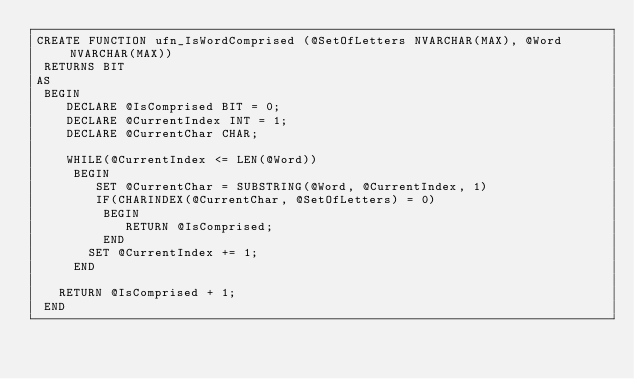Convert code to text. <code><loc_0><loc_0><loc_500><loc_500><_SQL_>CREATE FUNCTION ufn_IsWordComprised (@SetOfLetters NVARCHAR(MAX), @Word NVARCHAR(MAX))
 RETURNS BIT
AS
 BEGIN
	DECLARE @IsComprised BIT = 0;
	DECLARE @CurrentIndex INT = 1;
	DECLARE @CurrentChar CHAR;

	WHILE(@CurrentIndex <= LEN(@Word))
	 BEGIN
		SET @CurrentChar = SUBSTRING(@Word, @CurrentIndex, 1)
		IF(CHARINDEX(@CurrentChar, @SetOfLetters) = 0)
		 BEGIN
			RETURN @IsComprised;
		 END
	   SET @CurrentIndex += 1;
	 END

   RETURN @IsComprised + 1;
 END</code> 